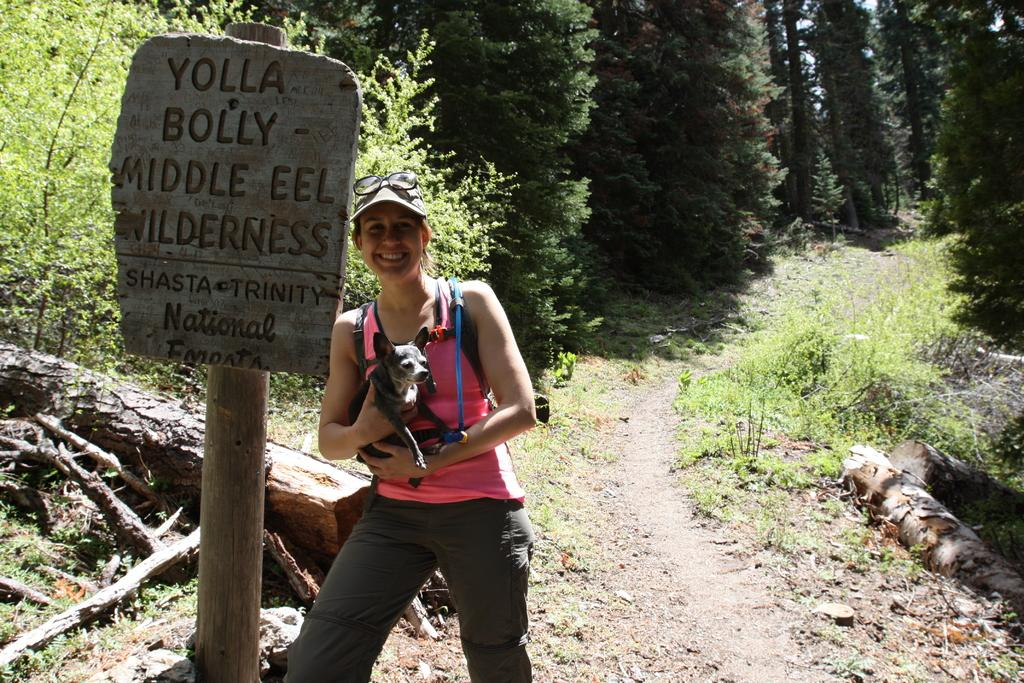What is the main subject of the image? The main subject of the image is a woman. What is the woman doing in the image? The woman is standing and smiling in the image. What is the woman holding in the image? The woman is holding a dog in the image. What can be seen attached to a pole in the image? There is a board attached to a pole in the image. What type of vegetation is visible in the background of the image? There are plants and trees in the background of the image. Can you tell me how many times the woman kicks the dog in the image? There is no indication in the image that the woman kicks the dog; she is holding the dog in a gentle manner. What type of quiver is the woman wearing in the image? There is no quiver present in the image; the woman is not wearing any type of quiver. 